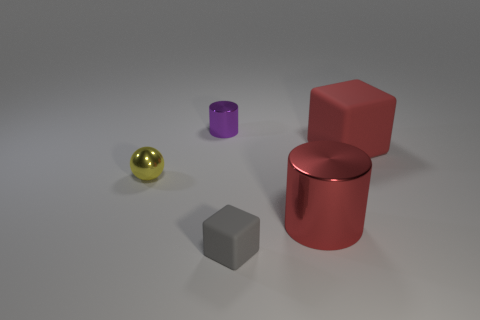Add 3 red things. How many objects exist? 8 Subtract all cylinders. How many objects are left? 3 Add 3 small metal cylinders. How many small metal cylinders are left? 4 Add 5 green cylinders. How many green cylinders exist? 5 Subtract all red cylinders. How many cylinders are left? 1 Subtract 0 gray balls. How many objects are left? 5 Subtract 1 cubes. How many cubes are left? 1 Subtract all cyan cylinders. Subtract all green cubes. How many cylinders are left? 2 Subtract all cyan spheres. How many red cylinders are left? 1 Subtract all big red cubes. Subtract all small blocks. How many objects are left? 3 